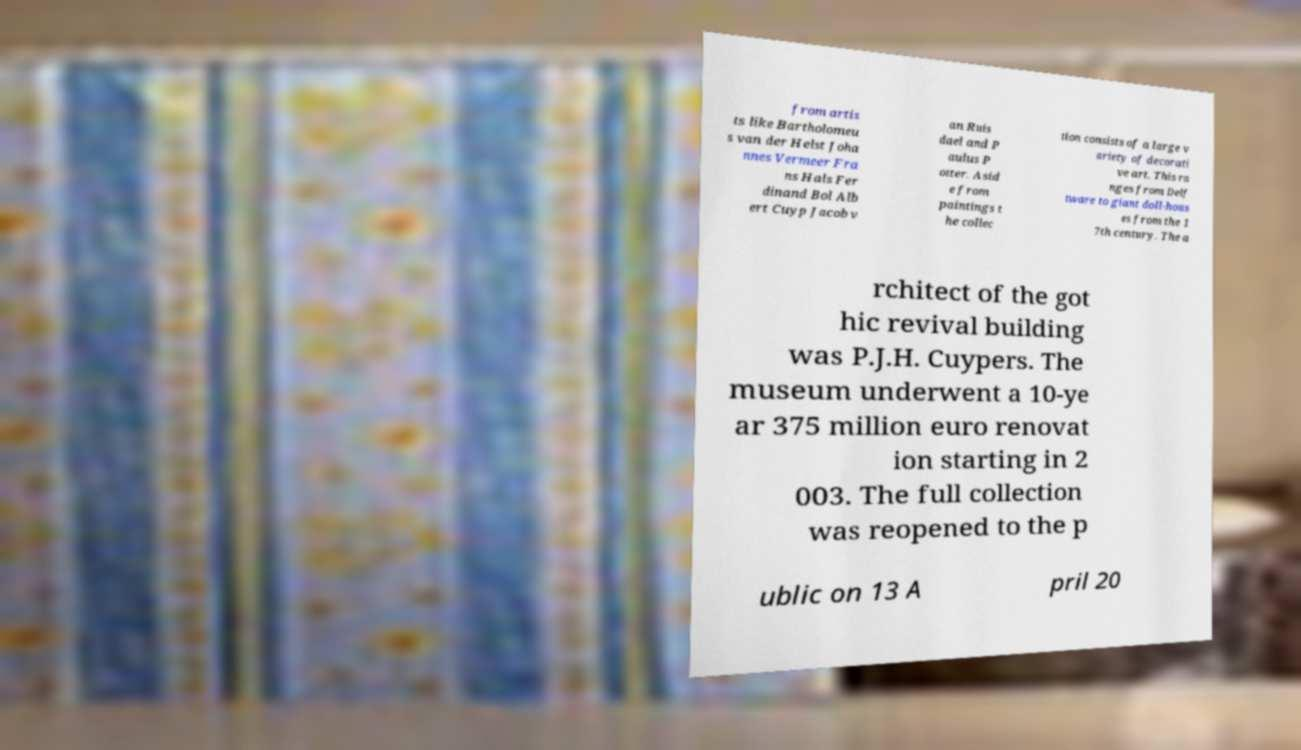Could you assist in decoding the text presented in this image and type it out clearly? from artis ts like Bartholomeu s van der Helst Joha nnes Vermeer Fra ns Hals Fer dinand Bol Alb ert Cuyp Jacob v an Ruis dael and P aulus P otter. Asid e from paintings t he collec tion consists of a large v ariety of decorati ve art. This ra nges from Delf tware to giant doll-hous es from the 1 7th century. The a rchitect of the got hic revival building was P.J.H. Cuypers. The museum underwent a 10-ye ar 375 million euro renovat ion starting in 2 003. The full collection was reopened to the p ublic on 13 A pril 20 